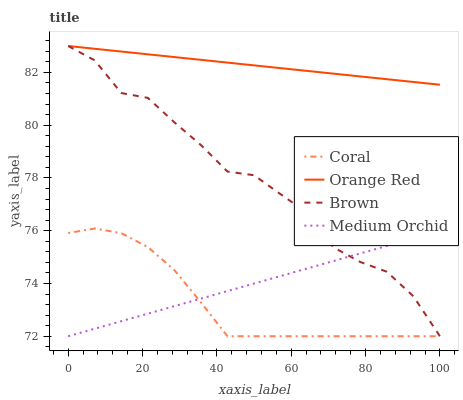Does Coral have the minimum area under the curve?
Answer yes or no. Yes. Does Orange Red have the maximum area under the curve?
Answer yes or no. Yes. Does Medium Orchid have the minimum area under the curve?
Answer yes or no. No. Does Medium Orchid have the maximum area under the curve?
Answer yes or no. No. Is Medium Orchid the smoothest?
Answer yes or no. Yes. Is Brown the roughest?
Answer yes or no. Yes. Is Coral the smoothest?
Answer yes or no. No. Is Coral the roughest?
Answer yes or no. No. Does Brown have the lowest value?
Answer yes or no. Yes. Does Orange Red have the lowest value?
Answer yes or no. No. Does Orange Red have the highest value?
Answer yes or no. Yes. Does Coral have the highest value?
Answer yes or no. No. Is Medium Orchid less than Orange Red?
Answer yes or no. Yes. Is Orange Red greater than Coral?
Answer yes or no. Yes. Does Medium Orchid intersect Brown?
Answer yes or no. Yes. Is Medium Orchid less than Brown?
Answer yes or no. No. Is Medium Orchid greater than Brown?
Answer yes or no. No. Does Medium Orchid intersect Orange Red?
Answer yes or no. No. 